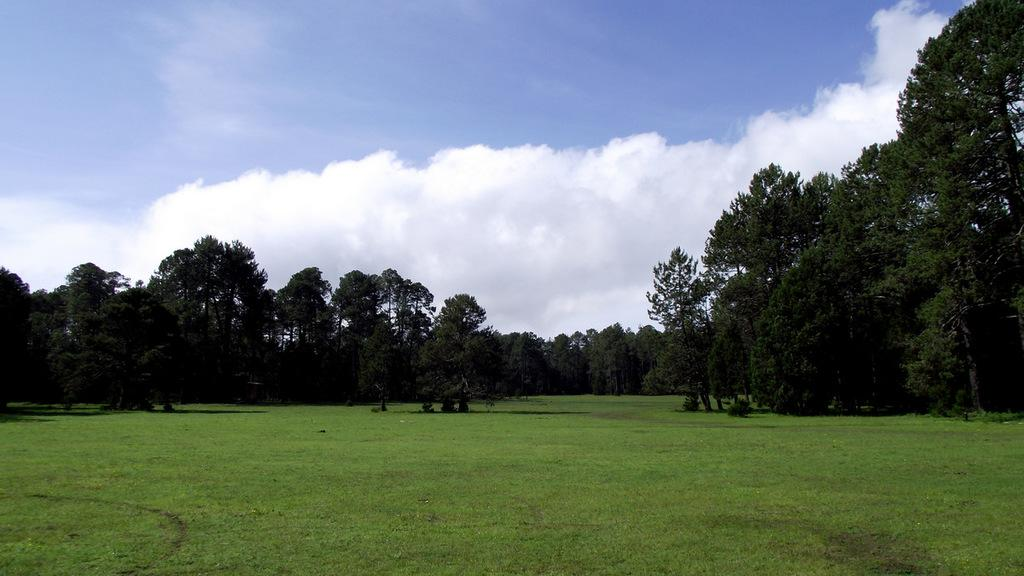What type of vegetation is present on the ground in the image? There is grass and trees on the ground in the image. What can be seen in the sky in the background of the image? There are clouds visible in the sky in the background of the image. Is there a toy buried in the dirt in the image? There is no dirt or toy present in the image; it features grass, trees, and clouds. Can you see a sidewalk in the image? There is no sidewalk present in the image; it features grass, trees, and clouds. 